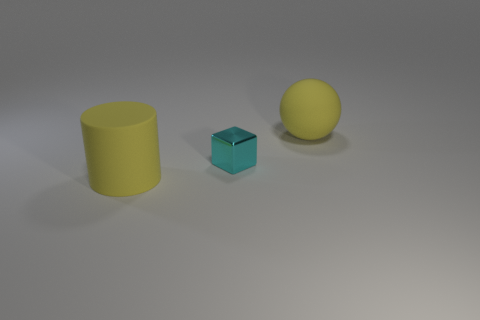Add 1 matte spheres. How many objects exist? 4 Subtract all balls. How many objects are left? 2 Subtract 1 balls. How many balls are left? 0 Subtract 0 red blocks. How many objects are left? 3 Subtract all cyan spheres. Subtract all green cubes. How many spheres are left? 1 Subtract all large green metal spheres. Subtract all big yellow balls. How many objects are left? 2 Add 1 small cyan objects. How many small cyan objects are left? 2 Add 2 big matte things. How many big matte things exist? 4 